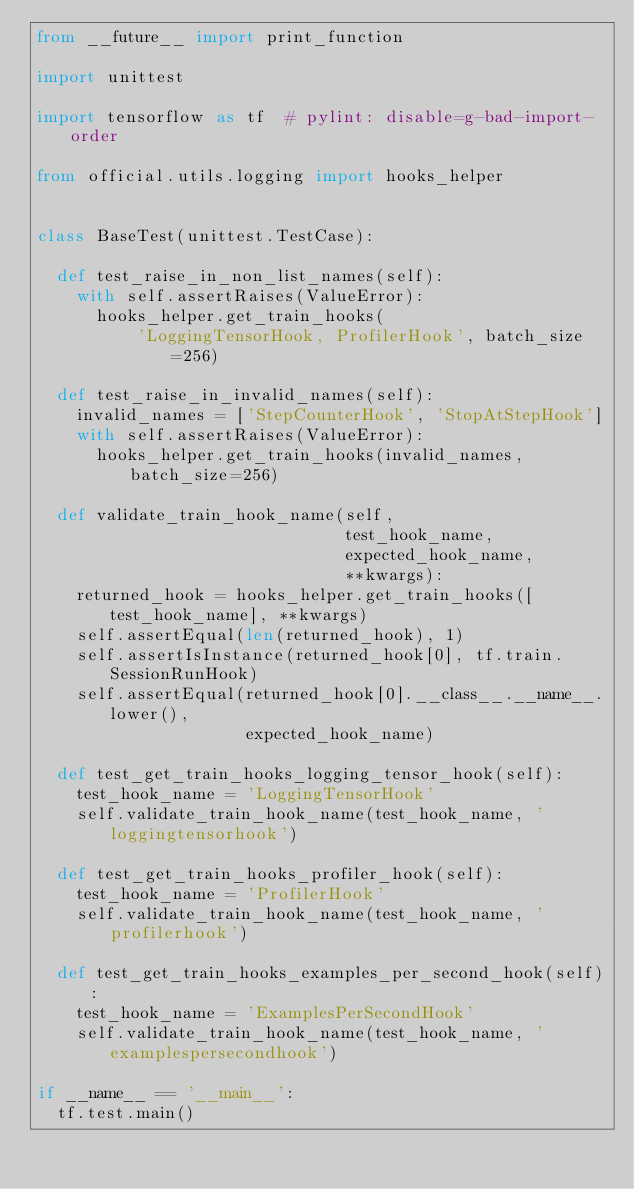<code> <loc_0><loc_0><loc_500><loc_500><_Python_>from __future__ import print_function

import unittest

import tensorflow as tf  # pylint: disable=g-bad-import-order

from official.utils.logging import hooks_helper


class BaseTest(unittest.TestCase):

  def test_raise_in_non_list_names(self):
    with self.assertRaises(ValueError):
      hooks_helper.get_train_hooks(
          'LoggingTensorHook, ProfilerHook', batch_size=256)

  def test_raise_in_invalid_names(self):
    invalid_names = ['StepCounterHook', 'StopAtStepHook']
    with self.assertRaises(ValueError):
      hooks_helper.get_train_hooks(invalid_names, batch_size=256)

  def validate_train_hook_name(self,
                               test_hook_name,
                               expected_hook_name,
                               **kwargs):
    returned_hook = hooks_helper.get_train_hooks([test_hook_name], **kwargs)
    self.assertEqual(len(returned_hook), 1)
    self.assertIsInstance(returned_hook[0], tf.train.SessionRunHook)
    self.assertEqual(returned_hook[0].__class__.__name__.lower(),
                     expected_hook_name)

  def test_get_train_hooks_logging_tensor_hook(self):
    test_hook_name = 'LoggingTensorHook'
    self.validate_train_hook_name(test_hook_name, 'loggingtensorhook')

  def test_get_train_hooks_profiler_hook(self):
    test_hook_name = 'ProfilerHook'
    self.validate_train_hook_name(test_hook_name, 'profilerhook')

  def test_get_train_hooks_examples_per_second_hook(self):
    test_hook_name = 'ExamplesPerSecondHook'
    self.validate_train_hook_name(test_hook_name, 'examplespersecondhook')

if __name__ == '__main__':
  tf.test.main()
</code> 